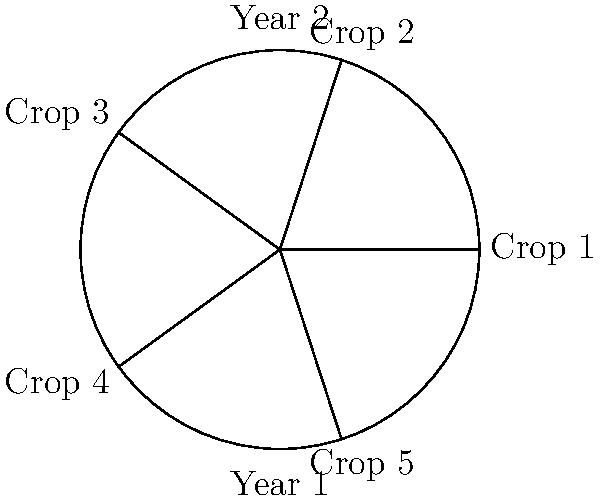As an agriculturist, you're planning a 5-year crop rotation cycle to protect your soil from industrial pollutants. The circular diagram represents your farm divided into 5 equal sections. If you start with Crop 1 in the topmost section and rotate clockwise each year, which crop will be in the topmost section in Year 3? Let's follow the rotation step-by-step:

1. In Year 1, Crop 1 is in the topmost section.
2. In Year 2, we rotate clockwise. Crop 5 moves to the top.
3. In Year 3, we rotate clockwise again.

To determine which crop is at the top in Year 3, we need to count two positions clockwise from Crop 1's initial position.

Starting from Crop 1 and moving clockwise:
- First clockwise move: Crop 5
- Second clockwise move: Crop 4

Therefore, in Year 3, Crop 4 will be in the topmost section.

This rotation pattern helps in:
1. Reducing soil depletion
2. Breaking pest and disease cycles
3. Improving soil structure
4. Potentially mitigating the effects of industrial pollutants by varying crop exposure
Answer: Crop 4 